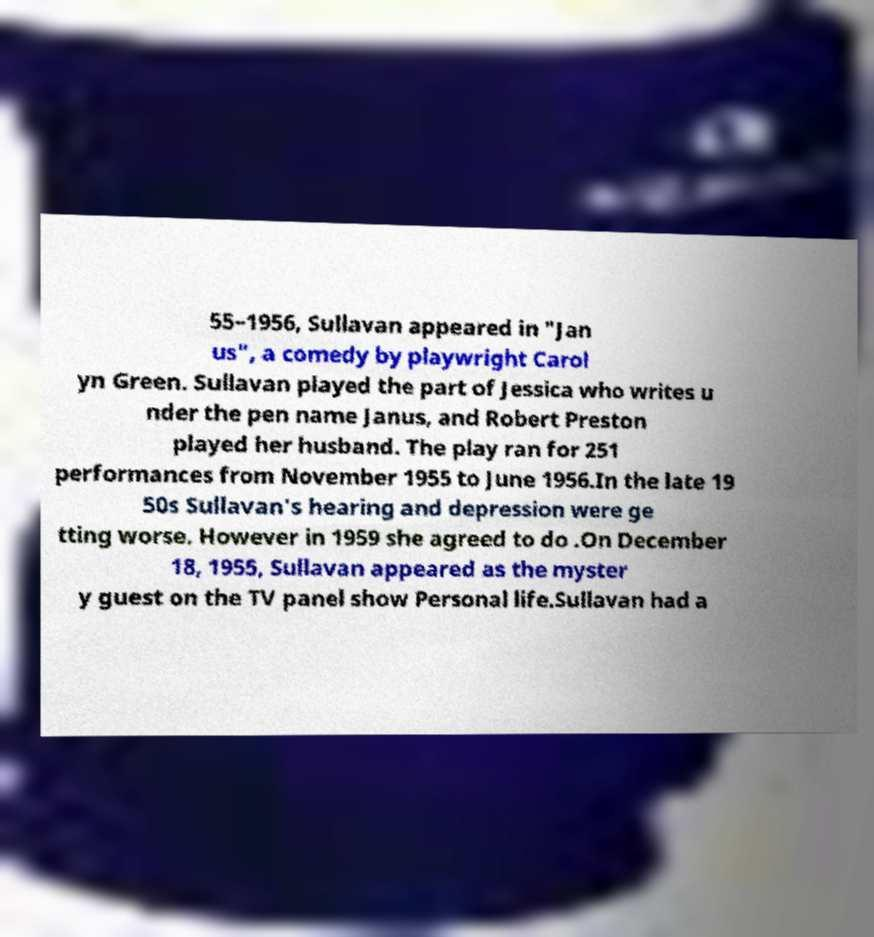Please identify and transcribe the text found in this image. 55–1956, Sullavan appeared in "Jan us", a comedy by playwright Carol yn Green. Sullavan played the part of Jessica who writes u nder the pen name Janus, and Robert Preston played her husband. The play ran for 251 performances from November 1955 to June 1956.In the late 19 50s Sullavan's hearing and depression were ge tting worse. However in 1959 she agreed to do .On December 18, 1955, Sullavan appeared as the myster y guest on the TV panel show Personal life.Sullavan had a 